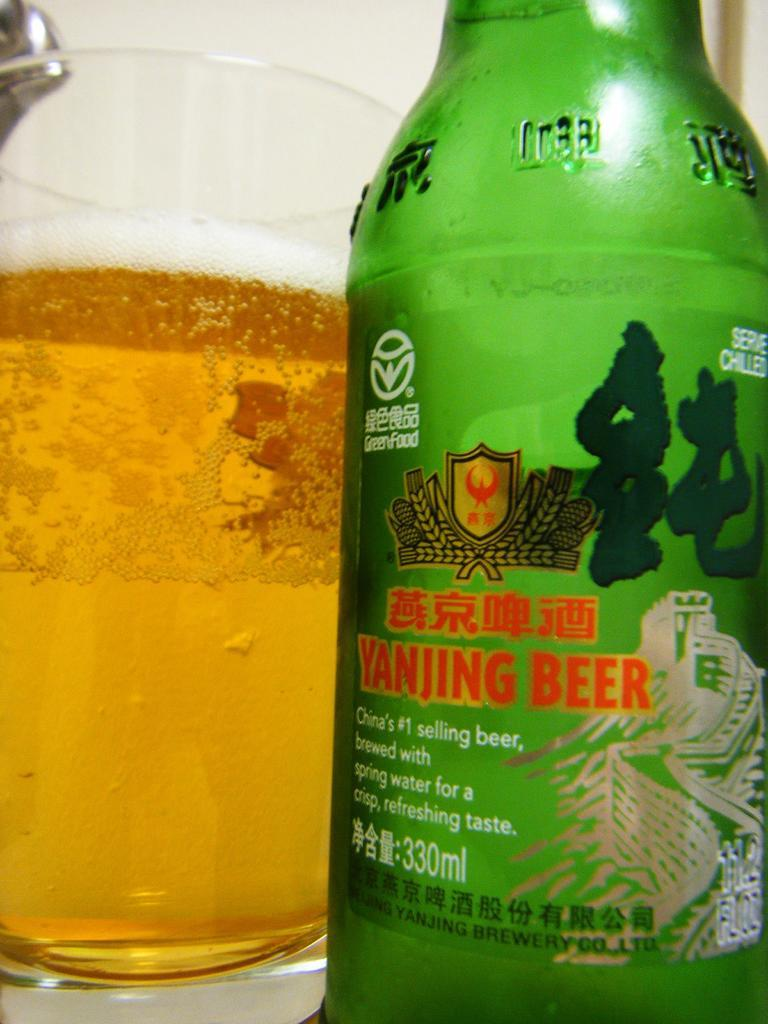Provide a one-sentence caption for the provided image. A close up shot of a Yanjing Beer bottle in front of a glass of beer. 